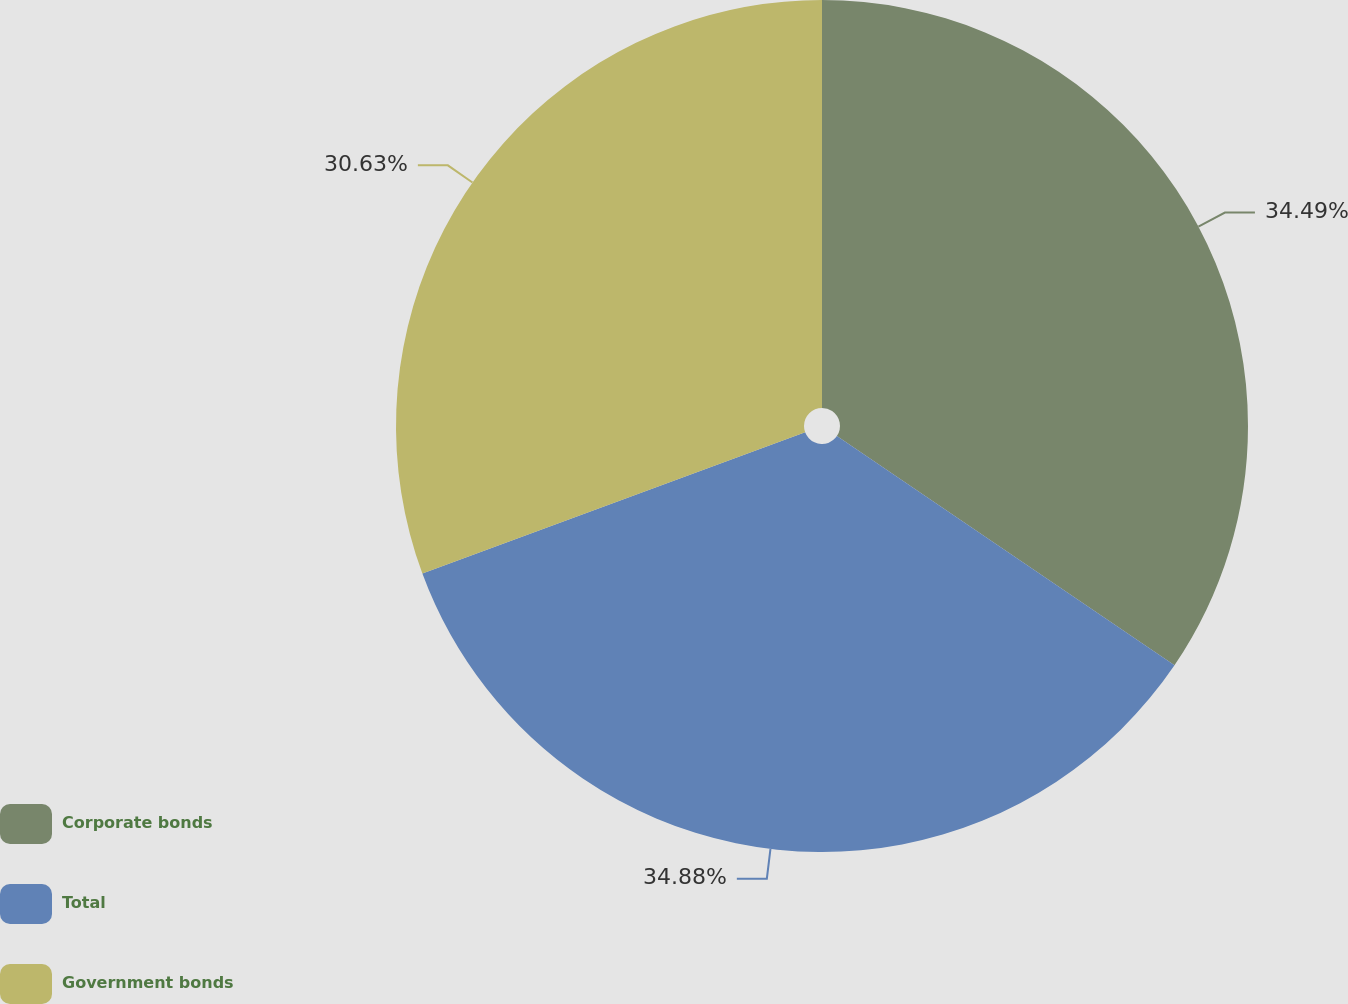Convert chart. <chart><loc_0><loc_0><loc_500><loc_500><pie_chart><fcel>Corporate bonds<fcel>Total<fcel>Government bonds<nl><fcel>34.49%<fcel>34.88%<fcel>30.63%<nl></chart> 